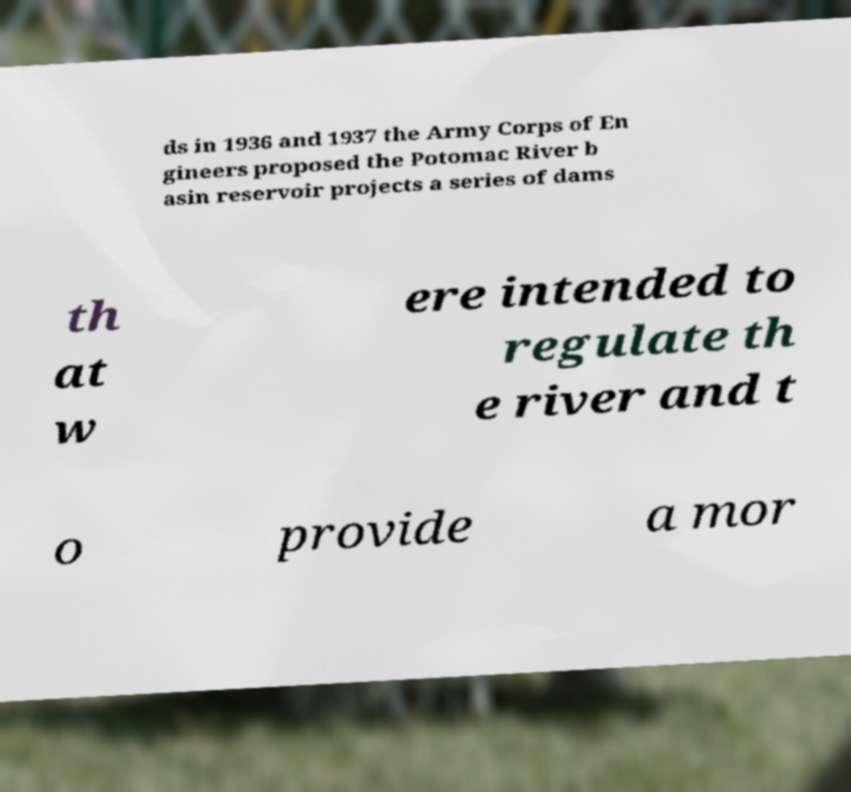Please identify and transcribe the text found in this image. ds in 1936 and 1937 the Army Corps of En gineers proposed the Potomac River b asin reservoir projects a series of dams th at w ere intended to regulate th e river and t o provide a mor 